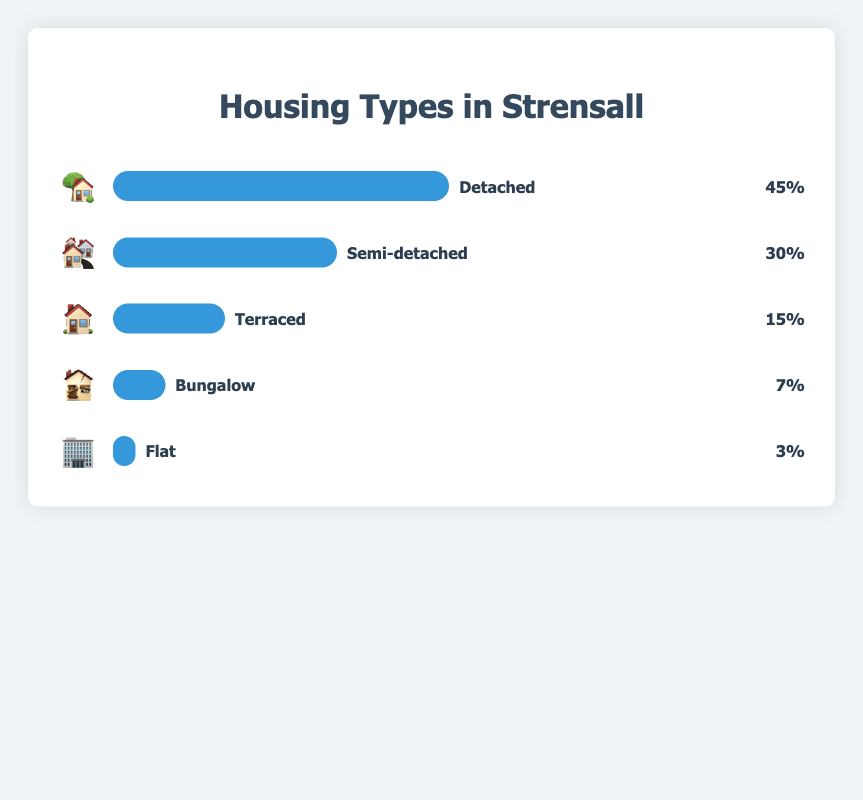What housing type is represented by the 🏡 emoji? 🏡 is associated with the label 'Detached' in the figure.
Answer: Detached Which housing type has the smallest percentage representation? The figure shows that the type with the smallest percentage is represented by the 🏢 emoji, which corresponds to "Flat" at 3%.
Answer: Flat What is the percentage difference between Detached and Semi-detached housing? Detached housing has a percentage of 45%, while Semi-detached housing has 30%. Subtract 30% from 45%, resulting in a 15% difference.
Answer: 15% List the housing types in descending order based on their percentage representation. The housing types in descending order are: Detached (45%), Semi-detached (30%), Terraced (15%), Bungalow (7%), and Flat (3%).
Answer: Detached, Semi-detached, Terraced, Bungalow, Flat What is the total percentage covered by Terraced, Bungalow, and Flat housing types combined? Add the percentages of Terraced (15%), Bungalow (7%), and Flat (3%) together: 15% + 7% + 3% = 25%.
Answer: 25% How much larger is the percentage of Detached housing compared to Bungalow housing? Detached housing is 45% and Bungalow housing is 7%. Subtract 7% from 45%, resulting in a 38% difference.
Answer: 38% If you were to combine Semi-detached and Terraced housing types, what would their combined percentage be? Semi-detached housing has a percentage of 30% and Terraced has 15%. Adding these together gives 30% + 15% = 45%.
Answer: 45% Which housing type is represented by the 🏘️ emoji and what is its percentage? 🏘️ is associated with the label 'Semi-detached' and its percentage is 30%.
Answer: Semi-detached, 30% Which two housing types together exactly match the percentage of Detached housing? Semi-detached and Terraced have percentages of 30% and 15% respectively. Adding them together gives 30% + 15% = 45%, which matches the Detached percentage.
Answer: Semi-detached and Terraced 